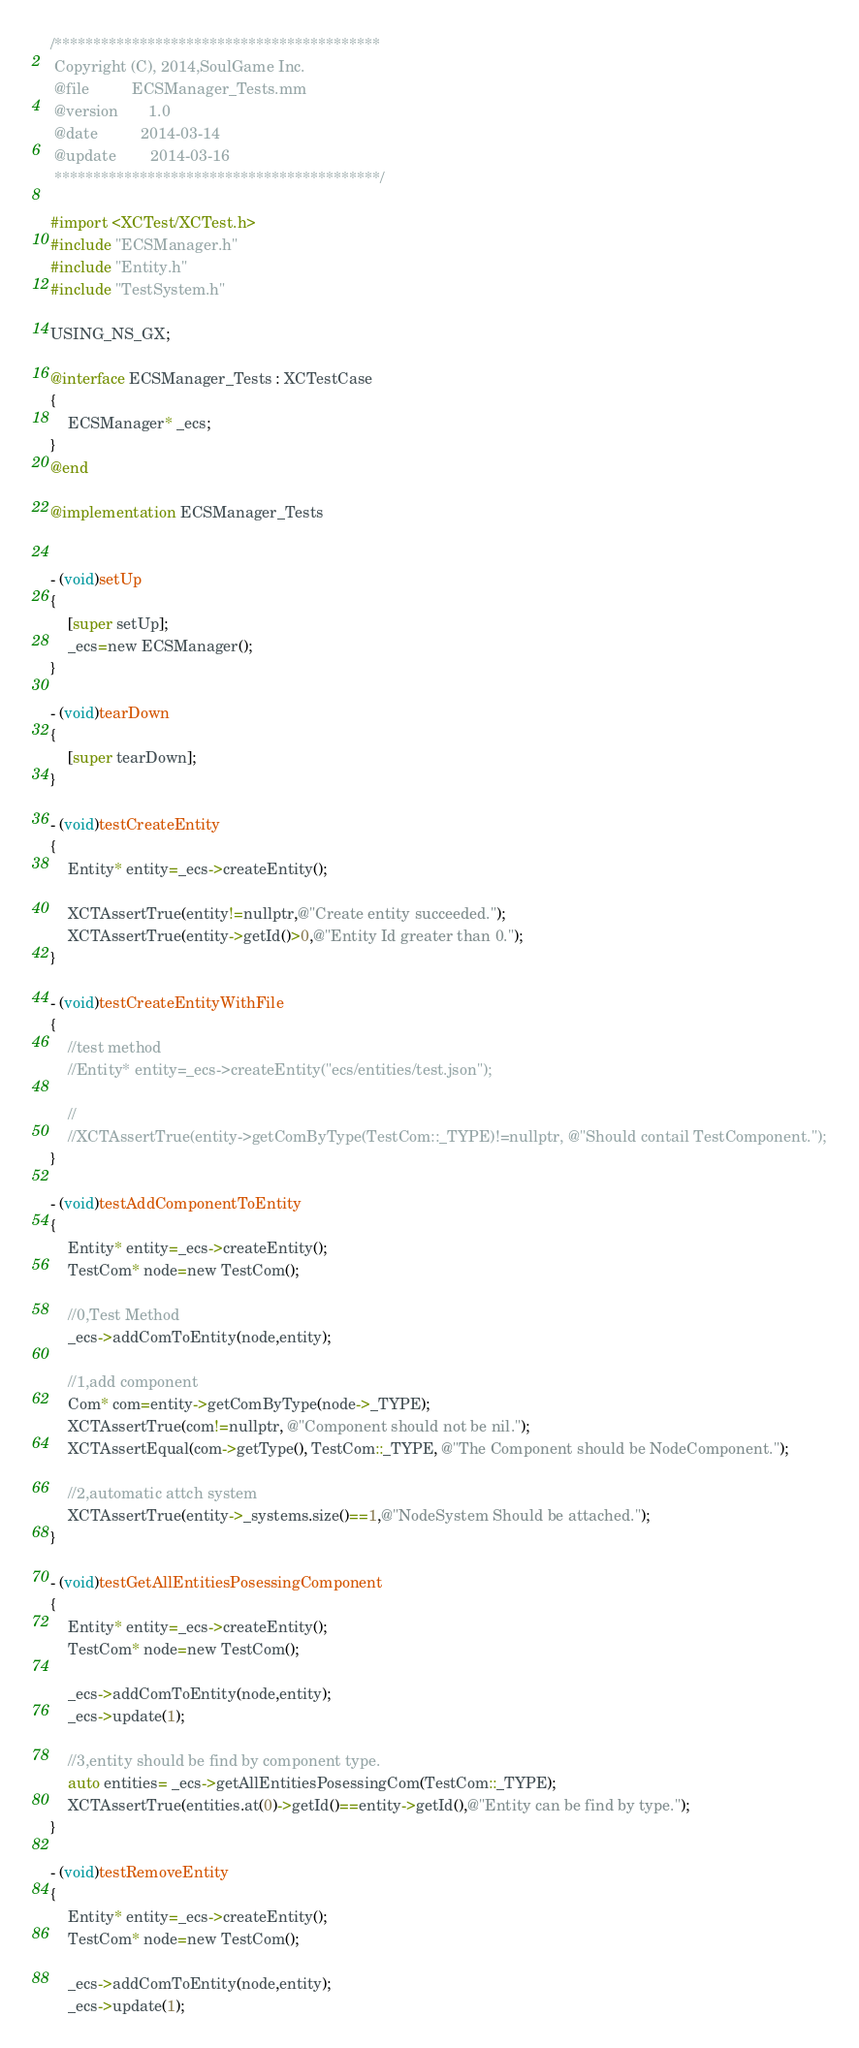<code> <loc_0><loc_0><loc_500><loc_500><_ObjectiveC_>/******************************************
 Copyright (C), 2014,SoulGame Inc.
 @file          ECSManager_Tests.mm
 @version       1.0
 @date          2014-03-14
 @update        2014-03-16
 ******************************************/

#import <XCTest/XCTest.h>
#include "ECSManager.h"
#include "Entity.h"
#include "TestSystem.h"

USING_NS_GX;

@interface ECSManager_Tests : XCTestCase
{
    ECSManager* _ecs;
}
@end

@implementation ECSManager_Tests


- (void)setUp
{
    [super setUp];
    _ecs=new ECSManager();
}

- (void)tearDown
{
    [super tearDown];
}

- (void)testCreateEntity
{
    Entity* entity=_ecs->createEntity();
    
    XCTAssertTrue(entity!=nullptr,@"Create entity succeeded.");
    XCTAssertTrue(entity->getId()>0,@"Entity Id greater than 0.");
}

- (void)testCreateEntityWithFile
{
    //test method
    //Entity* entity=_ecs->createEntity("ecs/entities/test.json");
    
    //
    //XCTAssertTrue(entity->getComByType(TestCom::_TYPE)!=nullptr, @"Should contail TestComponent.");
}

- (void)testAddComponentToEntity
{
    Entity* entity=_ecs->createEntity();
    TestCom* node=new TestCom();
    
    //0,Test Method
    _ecs->addComToEntity(node,entity);
    
    //1,add component
    Com* com=entity->getComByType(node->_TYPE);
    XCTAssertTrue(com!=nullptr, @"Component should not be nil.");
    XCTAssertEqual(com->getType(), TestCom::_TYPE, @"The Component should be NodeComponent.");
    
    //2,automatic attch system
    XCTAssertTrue(entity->_systems.size()==1,@"NodeSystem Should be attached.");
}

- (void)testGetAllEntitiesPosessingComponent
{
    Entity* entity=_ecs->createEntity();
    TestCom* node=new TestCom();
    
    _ecs->addComToEntity(node,entity);
    _ecs->update(1);
    
    //3,entity should be find by component type.
    auto entities= _ecs->getAllEntitiesPosessingCom(TestCom::_TYPE);
    XCTAssertTrue(entities.at(0)->getId()==entity->getId(),@"Entity can be find by type.");
}

- (void)testRemoveEntity
{
    Entity* entity=_ecs->createEntity();
    TestCom* node=new TestCom();
    
    _ecs->addComToEntity(node,entity);
    _ecs->update(1);</code> 